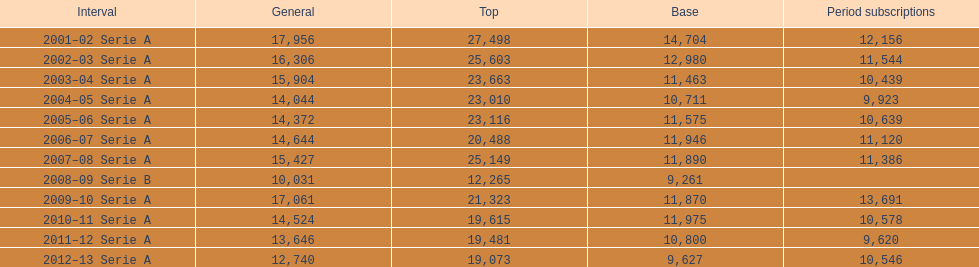What was the average in 2001 17,956. Could you parse the entire table as a dict? {'header': ['Interval', 'General', 'Top', 'Base', 'Period subscriptions'], 'rows': [['2001–02 Serie A', '17,956', '27,498', '14,704', '12,156'], ['2002–03 Serie A', '16,306', '25,603', '12,980', '11,544'], ['2003–04 Serie A', '15,904', '23,663', '11,463', '10,439'], ['2004–05 Serie A', '14,044', '23,010', '10,711', '9,923'], ['2005–06 Serie A', '14,372', '23,116', '11,575', '10,639'], ['2006–07 Serie A', '14,644', '20,488', '11,946', '11,120'], ['2007–08 Serie A', '15,427', '25,149', '11,890', '11,386'], ['2008–09 Serie B', '10,031', '12,265', '9,261', ''], ['2009–10 Serie A', '17,061', '21,323', '11,870', '13,691'], ['2010–11 Serie A', '14,524', '19,615', '11,975', '10,578'], ['2011–12 Serie A', '13,646', '19,481', '10,800', '9,620'], ['2012–13 Serie A', '12,740', '19,073', '9,627', '10,546']]} 